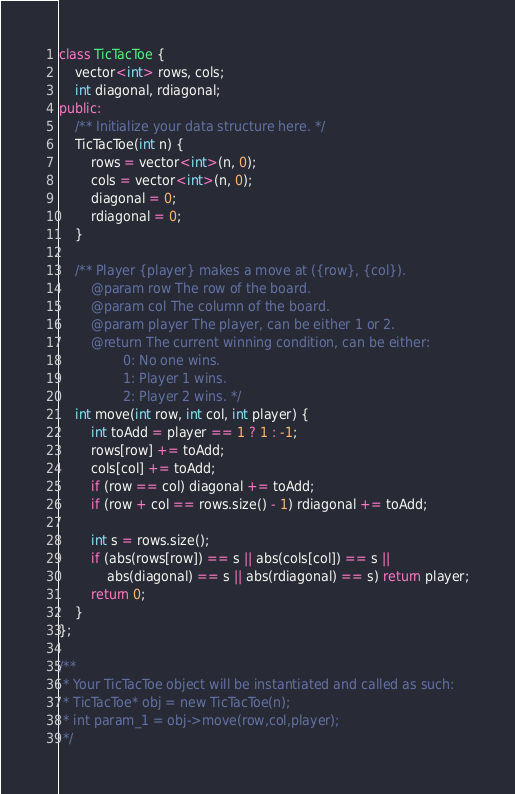<code> <loc_0><loc_0><loc_500><loc_500><_C++_>class TicTacToe {
    vector<int> rows, cols;
    int diagonal, rdiagonal;
public:
    /** Initialize your data structure here. */
    TicTacToe(int n) {
        rows = vector<int>(n, 0);
        cols = vector<int>(n, 0);
        diagonal = 0;
        rdiagonal = 0;
    }
    
    /** Player {player} makes a move at ({row}, {col}).
        @param row The row of the board.
        @param col The column of the board.
        @param player The player, can be either 1 or 2.
        @return The current winning condition, can be either:
                0: No one wins.
                1: Player 1 wins.
                2: Player 2 wins. */
    int move(int row, int col, int player) {
        int toAdd = player == 1 ? 1 : -1;
        rows[row] += toAdd;
        cols[col] += toAdd;
        if (row == col) diagonal += toAdd;
        if (row + col == rows.size() - 1) rdiagonal += toAdd;
        
        int s = rows.size();
        if (abs(rows[row]) == s || abs(cols[col]) == s ||
            abs(diagonal) == s || abs(rdiagonal) == s) return player;
        return 0;
    }
};

/**
 * Your TicTacToe object will be instantiated and called as such:
 * TicTacToe* obj = new TicTacToe(n);
 * int param_1 = obj->move(row,col,player);
 */</code> 